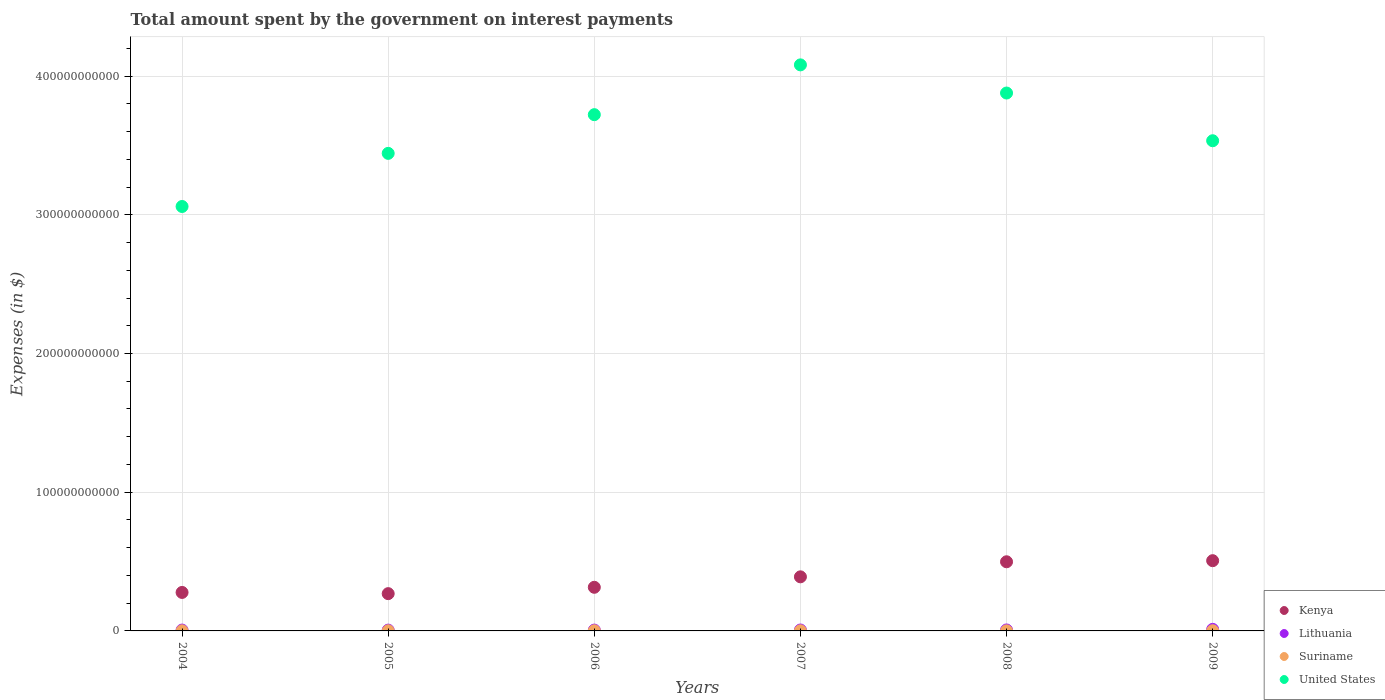Is the number of dotlines equal to the number of legend labels?
Provide a short and direct response. Yes. What is the amount spent on interest payments by the government in United States in 2004?
Your answer should be compact. 3.06e+11. Across all years, what is the maximum amount spent on interest payments by the government in Lithuania?
Offer a terse response. 1.13e+09. Across all years, what is the minimum amount spent on interest payments by the government in United States?
Give a very brief answer. 3.06e+11. In which year was the amount spent on interest payments by the government in Kenya maximum?
Provide a short and direct response. 2009. What is the total amount spent on interest payments by the government in Kenya in the graph?
Provide a succinct answer. 2.26e+11. What is the difference between the amount spent on interest payments by the government in Suriname in 2005 and that in 2007?
Give a very brief answer. 1.55e+05. What is the difference between the amount spent on interest payments by the government in United States in 2006 and the amount spent on interest payments by the government in Suriname in 2007?
Make the answer very short. 3.72e+11. What is the average amount spent on interest payments by the government in United States per year?
Your response must be concise. 3.62e+11. In the year 2006, what is the difference between the amount spent on interest payments by the government in Lithuania and amount spent on interest payments by the government in Kenya?
Provide a short and direct response. -3.09e+1. In how many years, is the amount spent on interest payments by the government in Suriname greater than 320000000000 $?
Give a very brief answer. 0. What is the ratio of the amount spent on interest payments by the government in United States in 2005 to that in 2007?
Offer a very short reply. 0.84. What is the difference between the highest and the second highest amount spent on interest payments by the government in Kenya?
Provide a succinct answer. 7.87e+08. What is the difference between the highest and the lowest amount spent on interest payments by the government in Suriname?
Keep it short and to the point. 7.16e+07. In how many years, is the amount spent on interest payments by the government in Kenya greater than the average amount spent on interest payments by the government in Kenya taken over all years?
Provide a short and direct response. 3. Is the sum of the amount spent on interest payments by the government in United States in 2005 and 2008 greater than the maximum amount spent on interest payments by the government in Suriname across all years?
Your answer should be very brief. Yes. Does the amount spent on interest payments by the government in United States monotonically increase over the years?
Ensure brevity in your answer.  No. How many dotlines are there?
Ensure brevity in your answer.  4. How many years are there in the graph?
Provide a short and direct response. 6. What is the difference between two consecutive major ticks on the Y-axis?
Give a very brief answer. 1.00e+11. Are the values on the major ticks of Y-axis written in scientific E-notation?
Give a very brief answer. No. Does the graph contain any zero values?
Provide a short and direct response. No. What is the title of the graph?
Ensure brevity in your answer.  Total amount spent by the government on interest payments. What is the label or title of the X-axis?
Your answer should be compact. Years. What is the label or title of the Y-axis?
Provide a succinct answer. Expenses (in $). What is the Expenses (in $) in Kenya in 2004?
Give a very brief answer. 2.77e+1. What is the Expenses (in $) in Lithuania in 2004?
Give a very brief answer. 6.10e+08. What is the Expenses (in $) of Suriname in 2004?
Your response must be concise. 6.82e+07. What is the Expenses (in $) in United States in 2004?
Your response must be concise. 3.06e+11. What is the Expenses (in $) in Kenya in 2005?
Make the answer very short. 2.69e+1. What is the Expenses (in $) in Lithuania in 2005?
Offer a very short reply. 5.87e+08. What is the Expenses (in $) in Suriname in 2005?
Your answer should be very brief. 9.73e+07. What is the Expenses (in $) of United States in 2005?
Offer a terse response. 3.44e+11. What is the Expenses (in $) of Kenya in 2006?
Your answer should be compact. 3.15e+1. What is the Expenses (in $) in Lithuania in 2006?
Ensure brevity in your answer.  6.00e+08. What is the Expenses (in $) in Suriname in 2006?
Ensure brevity in your answer.  1.08e+08. What is the Expenses (in $) in United States in 2006?
Provide a short and direct response. 3.72e+11. What is the Expenses (in $) of Kenya in 2007?
Give a very brief answer. 3.90e+1. What is the Expenses (in $) of Lithuania in 2007?
Offer a very short reply. 6.70e+08. What is the Expenses (in $) of Suriname in 2007?
Ensure brevity in your answer.  9.72e+07. What is the Expenses (in $) in United States in 2007?
Provide a short and direct response. 4.08e+11. What is the Expenses (in $) in Kenya in 2008?
Your response must be concise. 4.99e+1. What is the Expenses (in $) of Lithuania in 2008?
Your answer should be compact. 7.02e+08. What is the Expenses (in $) in Suriname in 2008?
Your answer should be very brief. 6.16e+07. What is the Expenses (in $) in United States in 2008?
Provide a short and direct response. 3.88e+11. What is the Expenses (in $) of Kenya in 2009?
Ensure brevity in your answer.  5.06e+1. What is the Expenses (in $) of Lithuania in 2009?
Ensure brevity in your answer.  1.13e+09. What is the Expenses (in $) of Suriname in 2009?
Your answer should be very brief. 1.33e+08. What is the Expenses (in $) in United States in 2009?
Provide a succinct answer. 3.53e+11. Across all years, what is the maximum Expenses (in $) in Kenya?
Provide a short and direct response. 5.06e+1. Across all years, what is the maximum Expenses (in $) of Lithuania?
Your answer should be compact. 1.13e+09. Across all years, what is the maximum Expenses (in $) of Suriname?
Your response must be concise. 1.33e+08. Across all years, what is the maximum Expenses (in $) of United States?
Make the answer very short. 4.08e+11. Across all years, what is the minimum Expenses (in $) of Kenya?
Provide a short and direct response. 2.69e+1. Across all years, what is the minimum Expenses (in $) in Lithuania?
Your answer should be very brief. 5.87e+08. Across all years, what is the minimum Expenses (in $) in Suriname?
Provide a succinct answer. 6.16e+07. Across all years, what is the minimum Expenses (in $) of United States?
Provide a short and direct response. 3.06e+11. What is the total Expenses (in $) in Kenya in the graph?
Your response must be concise. 2.26e+11. What is the total Expenses (in $) in Lithuania in the graph?
Your response must be concise. 4.30e+09. What is the total Expenses (in $) of Suriname in the graph?
Provide a succinct answer. 5.66e+08. What is the total Expenses (in $) of United States in the graph?
Provide a succinct answer. 2.17e+12. What is the difference between the Expenses (in $) in Kenya in 2004 and that in 2005?
Make the answer very short. 8.69e+08. What is the difference between the Expenses (in $) of Lithuania in 2004 and that in 2005?
Provide a short and direct response. 2.37e+07. What is the difference between the Expenses (in $) of Suriname in 2004 and that in 2005?
Your answer should be very brief. -2.91e+07. What is the difference between the Expenses (in $) of United States in 2004 and that in 2005?
Give a very brief answer. -3.83e+1. What is the difference between the Expenses (in $) of Kenya in 2004 and that in 2006?
Provide a short and direct response. -3.71e+09. What is the difference between the Expenses (in $) of Lithuania in 2004 and that in 2006?
Your answer should be very brief. 1.02e+07. What is the difference between the Expenses (in $) in Suriname in 2004 and that in 2006?
Provide a short and direct response. -4.02e+07. What is the difference between the Expenses (in $) of United States in 2004 and that in 2006?
Your answer should be compact. -6.62e+1. What is the difference between the Expenses (in $) in Kenya in 2004 and that in 2007?
Give a very brief answer. -1.13e+1. What is the difference between the Expenses (in $) in Lithuania in 2004 and that in 2007?
Offer a terse response. -6.00e+07. What is the difference between the Expenses (in $) of Suriname in 2004 and that in 2007?
Your answer should be very brief. -2.90e+07. What is the difference between the Expenses (in $) in United States in 2004 and that in 2007?
Keep it short and to the point. -1.02e+11. What is the difference between the Expenses (in $) in Kenya in 2004 and that in 2008?
Your answer should be very brief. -2.21e+1. What is the difference between the Expenses (in $) in Lithuania in 2004 and that in 2008?
Offer a terse response. -9.16e+07. What is the difference between the Expenses (in $) in Suriname in 2004 and that in 2008?
Your answer should be compact. 6.56e+06. What is the difference between the Expenses (in $) in United States in 2004 and that in 2008?
Make the answer very short. -8.18e+1. What is the difference between the Expenses (in $) in Kenya in 2004 and that in 2009?
Provide a short and direct response. -2.29e+1. What is the difference between the Expenses (in $) in Lithuania in 2004 and that in 2009?
Offer a very short reply. -5.17e+08. What is the difference between the Expenses (in $) in Suriname in 2004 and that in 2009?
Your answer should be very brief. -6.51e+07. What is the difference between the Expenses (in $) in United States in 2004 and that in 2009?
Make the answer very short. -4.74e+1. What is the difference between the Expenses (in $) of Kenya in 2005 and that in 2006?
Ensure brevity in your answer.  -4.58e+09. What is the difference between the Expenses (in $) of Lithuania in 2005 and that in 2006?
Make the answer very short. -1.35e+07. What is the difference between the Expenses (in $) in Suriname in 2005 and that in 2006?
Offer a very short reply. -1.11e+07. What is the difference between the Expenses (in $) of United States in 2005 and that in 2006?
Offer a very short reply. -2.79e+1. What is the difference between the Expenses (in $) of Kenya in 2005 and that in 2007?
Offer a very short reply. -1.21e+1. What is the difference between the Expenses (in $) in Lithuania in 2005 and that in 2007?
Make the answer very short. -8.37e+07. What is the difference between the Expenses (in $) in Suriname in 2005 and that in 2007?
Ensure brevity in your answer.  1.55e+05. What is the difference between the Expenses (in $) of United States in 2005 and that in 2007?
Offer a terse response. -6.38e+1. What is the difference between the Expenses (in $) of Kenya in 2005 and that in 2008?
Provide a short and direct response. -2.30e+1. What is the difference between the Expenses (in $) of Lithuania in 2005 and that in 2008?
Provide a succinct answer. -1.15e+08. What is the difference between the Expenses (in $) of Suriname in 2005 and that in 2008?
Your response must be concise. 3.57e+07. What is the difference between the Expenses (in $) of United States in 2005 and that in 2008?
Offer a very short reply. -4.35e+1. What is the difference between the Expenses (in $) of Kenya in 2005 and that in 2009?
Provide a short and direct response. -2.38e+1. What is the difference between the Expenses (in $) in Lithuania in 2005 and that in 2009?
Keep it short and to the point. -5.41e+08. What is the difference between the Expenses (in $) in Suriname in 2005 and that in 2009?
Provide a succinct answer. -3.60e+07. What is the difference between the Expenses (in $) in United States in 2005 and that in 2009?
Offer a terse response. -9.10e+09. What is the difference between the Expenses (in $) of Kenya in 2006 and that in 2007?
Ensure brevity in your answer.  -7.54e+09. What is the difference between the Expenses (in $) of Lithuania in 2006 and that in 2007?
Your response must be concise. -7.02e+07. What is the difference between the Expenses (in $) in Suriname in 2006 and that in 2007?
Offer a very short reply. 1.12e+07. What is the difference between the Expenses (in $) in United States in 2006 and that in 2007?
Offer a very short reply. -3.59e+1. What is the difference between the Expenses (in $) in Kenya in 2006 and that in 2008?
Your answer should be compact. -1.84e+1. What is the difference between the Expenses (in $) of Lithuania in 2006 and that in 2008?
Provide a short and direct response. -1.02e+08. What is the difference between the Expenses (in $) in Suriname in 2006 and that in 2008?
Your response must be concise. 4.68e+07. What is the difference between the Expenses (in $) in United States in 2006 and that in 2008?
Ensure brevity in your answer.  -1.56e+1. What is the difference between the Expenses (in $) in Kenya in 2006 and that in 2009?
Make the answer very short. -1.92e+1. What is the difference between the Expenses (in $) in Lithuania in 2006 and that in 2009?
Keep it short and to the point. -5.28e+08. What is the difference between the Expenses (in $) of Suriname in 2006 and that in 2009?
Provide a succinct answer. -2.49e+07. What is the difference between the Expenses (in $) of United States in 2006 and that in 2009?
Offer a very short reply. 1.88e+1. What is the difference between the Expenses (in $) in Kenya in 2007 and that in 2008?
Your answer should be very brief. -1.09e+1. What is the difference between the Expenses (in $) in Lithuania in 2007 and that in 2008?
Give a very brief answer. -3.16e+07. What is the difference between the Expenses (in $) of Suriname in 2007 and that in 2008?
Give a very brief answer. 3.55e+07. What is the difference between the Expenses (in $) in United States in 2007 and that in 2008?
Ensure brevity in your answer.  2.03e+1. What is the difference between the Expenses (in $) in Kenya in 2007 and that in 2009?
Your answer should be very brief. -1.16e+1. What is the difference between the Expenses (in $) in Lithuania in 2007 and that in 2009?
Provide a short and direct response. -4.57e+08. What is the difference between the Expenses (in $) in Suriname in 2007 and that in 2009?
Make the answer very short. -3.61e+07. What is the difference between the Expenses (in $) of United States in 2007 and that in 2009?
Provide a succinct answer. 5.47e+1. What is the difference between the Expenses (in $) in Kenya in 2008 and that in 2009?
Your answer should be very brief. -7.87e+08. What is the difference between the Expenses (in $) of Lithuania in 2008 and that in 2009?
Give a very brief answer. -4.26e+08. What is the difference between the Expenses (in $) in Suriname in 2008 and that in 2009?
Ensure brevity in your answer.  -7.16e+07. What is the difference between the Expenses (in $) in United States in 2008 and that in 2009?
Give a very brief answer. 3.44e+1. What is the difference between the Expenses (in $) of Kenya in 2004 and the Expenses (in $) of Lithuania in 2005?
Your answer should be very brief. 2.72e+1. What is the difference between the Expenses (in $) of Kenya in 2004 and the Expenses (in $) of Suriname in 2005?
Your answer should be very brief. 2.76e+1. What is the difference between the Expenses (in $) in Kenya in 2004 and the Expenses (in $) in United States in 2005?
Provide a succinct answer. -3.17e+11. What is the difference between the Expenses (in $) of Lithuania in 2004 and the Expenses (in $) of Suriname in 2005?
Your answer should be very brief. 5.13e+08. What is the difference between the Expenses (in $) in Lithuania in 2004 and the Expenses (in $) in United States in 2005?
Your answer should be very brief. -3.44e+11. What is the difference between the Expenses (in $) in Suriname in 2004 and the Expenses (in $) in United States in 2005?
Provide a short and direct response. -3.44e+11. What is the difference between the Expenses (in $) in Kenya in 2004 and the Expenses (in $) in Lithuania in 2006?
Provide a short and direct response. 2.71e+1. What is the difference between the Expenses (in $) in Kenya in 2004 and the Expenses (in $) in Suriname in 2006?
Your answer should be very brief. 2.76e+1. What is the difference between the Expenses (in $) in Kenya in 2004 and the Expenses (in $) in United States in 2006?
Offer a terse response. -3.44e+11. What is the difference between the Expenses (in $) of Lithuania in 2004 and the Expenses (in $) of Suriname in 2006?
Your answer should be very brief. 5.02e+08. What is the difference between the Expenses (in $) in Lithuania in 2004 and the Expenses (in $) in United States in 2006?
Give a very brief answer. -3.72e+11. What is the difference between the Expenses (in $) in Suriname in 2004 and the Expenses (in $) in United States in 2006?
Ensure brevity in your answer.  -3.72e+11. What is the difference between the Expenses (in $) in Kenya in 2004 and the Expenses (in $) in Lithuania in 2007?
Keep it short and to the point. 2.71e+1. What is the difference between the Expenses (in $) of Kenya in 2004 and the Expenses (in $) of Suriname in 2007?
Your response must be concise. 2.76e+1. What is the difference between the Expenses (in $) of Kenya in 2004 and the Expenses (in $) of United States in 2007?
Offer a terse response. -3.80e+11. What is the difference between the Expenses (in $) in Lithuania in 2004 and the Expenses (in $) in Suriname in 2007?
Provide a short and direct response. 5.13e+08. What is the difference between the Expenses (in $) of Lithuania in 2004 and the Expenses (in $) of United States in 2007?
Your answer should be very brief. -4.07e+11. What is the difference between the Expenses (in $) of Suriname in 2004 and the Expenses (in $) of United States in 2007?
Your answer should be compact. -4.08e+11. What is the difference between the Expenses (in $) in Kenya in 2004 and the Expenses (in $) in Lithuania in 2008?
Your response must be concise. 2.70e+1. What is the difference between the Expenses (in $) of Kenya in 2004 and the Expenses (in $) of Suriname in 2008?
Make the answer very short. 2.77e+1. What is the difference between the Expenses (in $) in Kenya in 2004 and the Expenses (in $) in United States in 2008?
Offer a very short reply. -3.60e+11. What is the difference between the Expenses (in $) of Lithuania in 2004 and the Expenses (in $) of Suriname in 2008?
Keep it short and to the point. 5.49e+08. What is the difference between the Expenses (in $) of Lithuania in 2004 and the Expenses (in $) of United States in 2008?
Offer a very short reply. -3.87e+11. What is the difference between the Expenses (in $) of Suriname in 2004 and the Expenses (in $) of United States in 2008?
Offer a very short reply. -3.88e+11. What is the difference between the Expenses (in $) in Kenya in 2004 and the Expenses (in $) in Lithuania in 2009?
Ensure brevity in your answer.  2.66e+1. What is the difference between the Expenses (in $) in Kenya in 2004 and the Expenses (in $) in Suriname in 2009?
Make the answer very short. 2.76e+1. What is the difference between the Expenses (in $) of Kenya in 2004 and the Expenses (in $) of United States in 2009?
Offer a very short reply. -3.26e+11. What is the difference between the Expenses (in $) of Lithuania in 2004 and the Expenses (in $) of Suriname in 2009?
Offer a terse response. 4.77e+08. What is the difference between the Expenses (in $) of Lithuania in 2004 and the Expenses (in $) of United States in 2009?
Your answer should be compact. -3.53e+11. What is the difference between the Expenses (in $) of Suriname in 2004 and the Expenses (in $) of United States in 2009?
Provide a succinct answer. -3.53e+11. What is the difference between the Expenses (in $) of Kenya in 2005 and the Expenses (in $) of Lithuania in 2006?
Offer a very short reply. 2.63e+1. What is the difference between the Expenses (in $) of Kenya in 2005 and the Expenses (in $) of Suriname in 2006?
Your answer should be compact. 2.68e+1. What is the difference between the Expenses (in $) of Kenya in 2005 and the Expenses (in $) of United States in 2006?
Your response must be concise. -3.45e+11. What is the difference between the Expenses (in $) of Lithuania in 2005 and the Expenses (in $) of Suriname in 2006?
Make the answer very short. 4.78e+08. What is the difference between the Expenses (in $) in Lithuania in 2005 and the Expenses (in $) in United States in 2006?
Your answer should be very brief. -3.72e+11. What is the difference between the Expenses (in $) of Suriname in 2005 and the Expenses (in $) of United States in 2006?
Your answer should be compact. -3.72e+11. What is the difference between the Expenses (in $) of Kenya in 2005 and the Expenses (in $) of Lithuania in 2007?
Give a very brief answer. 2.62e+1. What is the difference between the Expenses (in $) in Kenya in 2005 and the Expenses (in $) in Suriname in 2007?
Ensure brevity in your answer.  2.68e+1. What is the difference between the Expenses (in $) of Kenya in 2005 and the Expenses (in $) of United States in 2007?
Provide a short and direct response. -3.81e+11. What is the difference between the Expenses (in $) of Lithuania in 2005 and the Expenses (in $) of Suriname in 2007?
Offer a terse response. 4.90e+08. What is the difference between the Expenses (in $) of Lithuania in 2005 and the Expenses (in $) of United States in 2007?
Your response must be concise. -4.08e+11. What is the difference between the Expenses (in $) in Suriname in 2005 and the Expenses (in $) in United States in 2007?
Your response must be concise. -4.08e+11. What is the difference between the Expenses (in $) in Kenya in 2005 and the Expenses (in $) in Lithuania in 2008?
Provide a short and direct response. 2.62e+1. What is the difference between the Expenses (in $) in Kenya in 2005 and the Expenses (in $) in Suriname in 2008?
Keep it short and to the point. 2.68e+1. What is the difference between the Expenses (in $) in Kenya in 2005 and the Expenses (in $) in United States in 2008?
Offer a very short reply. -3.61e+11. What is the difference between the Expenses (in $) in Lithuania in 2005 and the Expenses (in $) in Suriname in 2008?
Offer a terse response. 5.25e+08. What is the difference between the Expenses (in $) of Lithuania in 2005 and the Expenses (in $) of United States in 2008?
Give a very brief answer. -3.87e+11. What is the difference between the Expenses (in $) of Suriname in 2005 and the Expenses (in $) of United States in 2008?
Make the answer very short. -3.88e+11. What is the difference between the Expenses (in $) of Kenya in 2005 and the Expenses (in $) of Lithuania in 2009?
Ensure brevity in your answer.  2.57e+1. What is the difference between the Expenses (in $) of Kenya in 2005 and the Expenses (in $) of Suriname in 2009?
Make the answer very short. 2.67e+1. What is the difference between the Expenses (in $) in Kenya in 2005 and the Expenses (in $) in United States in 2009?
Offer a terse response. -3.27e+11. What is the difference between the Expenses (in $) of Lithuania in 2005 and the Expenses (in $) of Suriname in 2009?
Make the answer very short. 4.54e+08. What is the difference between the Expenses (in $) of Lithuania in 2005 and the Expenses (in $) of United States in 2009?
Provide a succinct answer. -3.53e+11. What is the difference between the Expenses (in $) in Suriname in 2005 and the Expenses (in $) in United States in 2009?
Offer a very short reply. -3.53e+11. What is the difference between the Expenses (in $) in Kenya in 2006 and the Expenses (in $) in Lithuania in 2007?
Provide a succinct answer. 3.08e+1. What is the difference between the Expenses (in $) of Kenya in 2006 and the Expenses (in $) of Suriname in 2007?
Make the answer very short. 3.14e+1. What is the difference between the Expenses (in $) in Kenya in 2006 and the Expenses (in $) in United States in 2007?
Offer a terse response. -3.77e+11. What is the difference between the Expenses (in $) of Lithuania in 2006 and the Expenses (in $) of Suriname in 2007?
Ensure brevity in your answer.  5.03e+08. What is the difference between the Expenses (in $) of Lithuania in 2006 and the Expenses (in $) of United States in 2007?
Keep it short and to the point. -4.07e+11. What is the difference between the Expenses (in $) in Suriname in 2006 and the Expenses (in $) in United States in 2007?
Your answer should be very brief. -4.08e+11. What is the difference between the Expenses (in $) of Kenya in 2006 and the Expenses (in $) of Lithuania in 2008?
Your response must be concise. 3.08e+1. What is the difference between the Expenses (in $) of Kenya in 2006 and the Expenses (in $) of Suriname in 2008?
Keep it short and to the point. 3.14e+1. What is the difference between the Expenses (in $) in Kenya in 2006 and the Expenses (in $) in United States in 2008?
Provide a short and direct response. -3.56e+11. What is the difference between the Expenses (in $) in Lithuania in 2006 and the Expenses (in $) in Suriname in 2008?
Ensure brevity in your answer.  5.39e+08. What is the difference between the Expenses (in $) of Lithuania in 2006 and the Expenses (in $) of United States in 2008?
Make the answer very short. -3.87e+11. What is the difference between the Expenses (in $) of Suriname in 2006 and the Expenses (in $) of United States in 2008?
Keep it short and to the point. -3.88e+11. What is the difference between the Expenses (in $) of Kenya in 2006 and the Expenses (in $) of Lithuania in 2009?
Your answer should be compact. 3.03e+1. What is the difference between the Expenses (in $) of Kenya in 2006 and the Expenses (in $) of Suriname in 2009?
Offer a terse response. 3.13e+1. What is the difference between the Expenses (in $) in Kenya in 2006 and the Expenses (in $) in United States in 2009?
Your response must be concise. -3.22e+11. What is the difference between the Expenses (in $) of Lithuania in 2006 and the Expenses (in $) of Suriname in 2009?
Provide a short and direct response. 4.67e+08. What is the difference between the Expenses (in $) of Lithuania in 2006 and the Expenses (in $) of United States in 2009?
Keep it short and to the point. -3.53e+11. What is the difference between the Expenses (in $) in Suriname in 2006 and the Expenses (in $) in United States in 2009?
Provide a succinct answer. -3.53e+11. What is the difference between the Expenses (in $) in Kenya in 2007 and the Expenses (in $) in Lithuania in 2008?
Make the answer very short. 3.83e+1. What is the difference between the Expenses (in $) in Kenya in 2007 and the Expenses (in $) in Suriname in 2008?
Your response must be concise. 3.89e+1. What is the difference between the Expenses (in $) in Kenya in 2007 and the Expenses (in $) in United States in 2008?
Make the answer very short. -3.49e+11. What is the difference between the Expenses (in $) of Lithuania in 2007 and the Expenses (in $) of Suriname in 2008?
Your answer should be compact. 6.09e+08. What is the difference between the Expenses (in $) in Lithuania in 2007 and the Expenses (in $) in United States in 2008?
Keep it short and to the point. -3.87e+11. What is the difference between the Expenses (in $) of Suriname in 2007 and the Expenses (in $) of United States in 2008?
Your answer should be compact. -3.88e+11. What is the difference between the Expenses (in $) in Kenya in 2007 and the Expenses (in $) in Lithuania in 2009?
Your response must be concise. 3.79e+1. What is the difference between the Expenses (in $) in Kenya in 2007 and the Expenses (in $) in Suriname in 2009?
Keep it short and to the point. 3.89e+1. What is the difference between the Expenses (in $) in Kenya in 2007 and the Expenses (in $) in United States in 2009?
Your answer should be compact. -3.14e+11. What is the difference between the Expenses (in $) of Lithuania in 2007 and the Expenses (in $) of Suriname in 2009?
Your answer should be very brief. 5.37e+08. What is the difference between the Expenses (in $) in Lithuania in 2007 and the Expenses (in $) in United States in 2009?
Give a very brief answer. -3.53e+11. What is the difference between the Expenses (in $) in Suriname in 2007 and the Expenses (in $) in United States in 2009?
Provide a succinct answer. -3.53e+11. What is the difference between the Expenses (in $) of Kenya in 2008 and the Expenses (in $) of Lithuania in 2009?
Offer a very short reply. 4.87e+1. What is the difference between the Expenses (in $) in Kenya in 2008 and the Expenses (in $) in Suriname in 2009?
Offer a terse response. 4.97e+1. What is the difference between the Expenses (in $) in Kenya in 2008 and the Expenses (in $) in United States in 2009?
Give a very brief answer. -3.04e+11. What is the difference between the Expenses (in $) in Lithuania in 2008 and the Expenses (in $) in Suriname in 2009?
Offer a very short reply. 5.69e+08. What is the difference between the Expenses (in $) in Lithuania in 2008 and the Expenses (in $) in United States in 2009?
Offer a very short reply. -3.53e+11. What is the difference between the Expenses (in $) in Suriname in 2008 and the Expenses (in $) in United States in 2009?
Make the answer very short. -3.53e+11. What is the average Expenses (in $) of Kenya per year?
Give a very brief answer. 3.76e+1. What is the average Expenses (in $) in Lithuania per year?
Provide a succinct answer. 7.16e+08. What is the average Expenses (in $) of Suriname per year?
Your response must be concise. 9.43e+07. What is the average Expenses (in $) in United States per year?
Provide a succinct answer. 3.62e+11. In the year 2004, what is the difference between the Expenses (in $) of Kenya and Expenses (in $) of Lithuania?
Provide a short and direct response. 2.71e+1. In the year 2004, what is the difference between the Expenses (in $) in Kenya and Expenses (in $) in Suriname?
Your response must be concise. 2.77e+1. In the year 2004, what is the difference between the Expenses (in $) of Kenya and Expenses (in $) of United States?
Ensure brevity in your answer.  -2.78e+11. In the year 2004, what is the difference between the Expenses (in $) of Lithuania and Expenses (in $) of Suriname?
Ensure brevity in your answer.  5.42e+08. In the year 2004, what is the difference between the Expenses (in $) in Lithuania and Expenses (in $) in United States?
Your answer should be very brief. -3.05e+11. In the year 2004, what is the difference between the Expenses (in $) in Suriname and Expenses (in $) in United States?
Make the answer very short. -3.06e+11. In the year 2005, what is the difference between the Expenses (in $) in Kenya and Expenses (in $) in Lithuania?
Offer a terse response. 2.63e+1. In the year 2005, what is the difference between the Expenses (in $) in Kenya and Expenses (in $) in Suriname?
Keep it short and to the point. 2.68e+1. In the year 2005, what is the difference between the Expenses (in $) in Kenya and Expenses (in $) in United States?
Ensure brevity in your answer.  -3.17e+11. In the year 2005, what is the difference between the Expenses (in $) of Lithuania and Expenses (in $) of Suriname?
Your answer should be very brief. 4.89e+08. In the year 2005, what is the difference between the Expenses (in $) in Lithuania and Expenses (in $) in United States?
Your answer should be very brief. -3.44e+11. In the year 2005, what is the difference between the Expenses (in $) in Suriname and Expenses (in $) in United States?
Provide a succinct answer. -3.44e+11. In the year 2006, what is the difference between the Expenses (in $) of Kenya and Expenses (in $) of Lithuania?
Your answer should be compact. 3.09e+1. In the year 2006, what is the difference between the Expenses (in $) in Kenya and Expenses (in $) in Suriname?
Offer a terse response. 3.13e+1. In the year 2006, what is the difference between the Expenses (in $) of Kenya and Expenses (in $) of United States?
Make the answer very short. -3.41e+11. In the year 2006, what is the difference between the Expenses (in $) of Lithuania and Expenses (in $) of Suriname?
Offer a terse response. 4.92e+08. In the year 2006, what is the difference between the Expenses (in $) in Lithuania and Expenses (in $) in United States?
Your answer should be very brief. -3.72e+11. In the year 2006, what is the difference between the Expenses (in $) in Suriname and Expenses (in $) in United States?
Ensure brevity in your answer.  -3.72e+11. In the year 2007, what is the difference between the Expenses (in $) in Kenya and Expenses (in $) in Lithuania?
Give a very brief answer. 3.83e+1. In the year 2007, what is the difference between the Expenses (in $) in Kenya and Expenses (in $) in Suriname?
Make the answer very short. 3.89e+1. In the year 2007, what is the difference between the Expenses (in $) in Kenya and Expenses (in $) in United States?
Offer a very short reply. -3.69e+11. In the year 2007, what is the difference between the Expenses (in $) in Lithuania and Expenses (in $) in Suriname?
Provide a short and direct response. 5.73e+08. In the year 2007, what is the difference between the Expenses (in $) in Lithuania and Expenses (in $) in United States?
Your answer should be compact. -4.07e+11. In the year 2007, what is the difference between the Expenses (in $) of Suriname and Expenses (in $) of United States?
Keep it short and to the point. -4.08e+11. In the year 2008, what is the difference between the Expenses (in $) in Kenya and Expenses (in $) in Lithuania?
Give a very brief answer. 4.92e+1. In the year 2008, what is the difference between the Expenses (in $) of Kenya and Expenses (in $) of Suriname?
Offer a terse response. 4.98e+1. In the year 2008, what is the difference between the Expenses (in $) in Kenya and Expenses (in $) in United States?
Make the answer very short. -3.38e+11. In the year 2008, what is the difference between the Expenses (in $) in Lithuania and Expenses (in $) in Suriname?
Offer a terse response. 6.40e+08. In the year 2008, what is the difference between the Expenses (in $) of Lithuania and Expenses (in $) of United States?
Keep it short and to the point. -3.87e+11. In the year 2008, what is the difference between the Expenses (in $) in Suriname and Expenses (in $) in United States?
Keep it short and to the point. -3.88e+11. In the year 2009, what is the difference between the Expenses (in $) of Kenya and Expenses (in $) of Lithuania?
Provide a short and direct response. 4.95e+1. In the year 2009, what is the difference between the Expenses (in $) of Kenya and Expenses (in $) of Suriname?
Provide a short and direct response. 5.05e+1. In the year 2009, what is the difference between the Expenses (in $) in Kenya and Expenses (in $) in United States?
Provide a succinct answer. -3.03e+11. In the year 2009, what is the difference between the Expenses (in $) of Lithuania and Expenses (in $) of Suriname?
Offer a very short reply. 9.95e+08. In the year 2009, what is the difference between the Expenses (in $) in Lithuania and Expenses (in $) in United States?
Your response must be concise. -3.52e+11. In the year 2009, what is the difference between the Expenses (in $) of Suriname and Expenses (in $) of United States?
Ensure brevity in your answer.  -3.53e+11. What is the ratio of the Expenses (in $) in Kenya in 2004 to that in 2005?
Offer a very short reply. 1.03. What is the ratio of the Expenses (in $) of Lithuania in 2004 to that in 2005?
Provide a succinct answer. 1.04. What is the ratio of the Expenses (in $) of Suriname in 2004 to that in 2005?
Your answer should be compact. 0.7. What is the ratio of the Expenses (in $) in United States in 2004 to that in 2005?
Provide a succinct answer. 0.89. What is the ratio of the Expenses (in $) in Kenya in 2004 to that in 2006?
Keep it short and to the point. 0.88. What is the ratio of the Expenses (in $) in Lithuania in 2004 to that in 2006?
Offer a terse response. 1.02. What is the ratio of the Expenses (in $) in Suriname in 2004 to that in 2006?
Ensure brevity in your answer.  0.63. What is the ratio of the Expenses (in $) in United States in 2004 to that in 2006?
Offer a terse response. 0.82. What is the ratio of the Expenses (in $) in Kenya in 2004 to that in 2007?
Your answer should be very brief. 0.71. What is the ratio of the Expenses (in $) of Lithuania in 2004 to that in 2007?
Give a very brief answer. 0.91. What is the ratio of the Expenses (in $) in Suriname in 2004 to that in 2007?
Offer a terse response. 0.7. What is the ratio of the Expenses (in $) of United States in 2004 to that in 2007?
Ensure brevity in your answer.  0.75. What is the ratio of the Expenses (in $) of Kenya in 2004 to that in 2008?
Ensure brevity in your answer.  0.56. What is the ratio of the Expenses (in $) in Lithuania in 2004 to that in 2008?
Give a very brief answer. 0.87. What is the ratio of the Expenses (in $) in Suriname in 2004 to that in 2008?
Offer a terse response. 1.11. What is the ratio of the Expenses (in $) in United States in 2004 to that in 2008?
Your answer should be very brief. 0.79. What is the ratio of the Expenses (in $) of Kenya in 2004 to that in 2009?
Provide a short and direct response. 0.55. What is the ratio of the Expenses (in $) in Lithuania in 2004 to that in 2009?
Your response must be concise. 0.54. What is the ratio of the Expenses (in $) of Suriname in 2004 to that in 2009?
Provide a short and direct response. 0.51. What is the ratio of the Expenses (in $) of United States in 2004 to that in 2009?
Your answer should be very brief. 0.87. What is the ratio of the Expenses (in $) of Kenya in 2005 to that in 2006?
Give a very brief answer. 0.85. What is the ratio of the Expenses (in $) of Lithuania in 2005 to that in 2006?
Your response must be concise. 0.98. What is the ratio of the Expenses (in $) in Suriname in 2005 to that in 2006?
Ensure brevity in your answer.  0.9. What is the ratio of the Expenses (in $) of United States in 2005 to that in 2006?
Give a very brief answer. 0.93. What is the ratio of the Expenses (in $) of Kenya in 2005 to that in 2007?
Your answer should be very brief. 0.69. What is the ratio of the Expenses (in $) of Lithuania in 2005 to that in 2007?
Your response must be concise. 0.88. What is the ratio of the Expenses (in $) of United States in 2005 to that in 2007?
Your answer should be compact. 0.84. What is the ratio of the Expenses (in $) of Kenya in 2005 to that in 2008?
Offer a very short reply. 0.54. What is the ratio of the Expenses (in $) in Lithuania in 2005 to that in 2008?
Your answer should be compact. 0.84. What is the ratio of the Expenses (in $) in Suriname in 2005 to that in 2008?
Your response must be concise. 1.58. What is the ratio of the Expenses (in $) of United States in 2005 to that in 2008?
Your answer should be very brief. 0.89. What is the ratio of the Expenses (in $) of Kenya in 2005 to that in 2009?
Ensure brevity in your answer.  0.53. What is the ratio of the Expenses (in $) in Lithuania in 2005 to that in 2009?
Provide a succinct answer. 0.52. What is the ratio of the Expenses (in $) in Suriname in 2005 to that in 2009?
Provide a short and direct response. 0.73. What is the ratio of the Expenses (in $) of United States in 2005 to that in 2009?
Your answer should be very brief. 0.97. What is the ratio of the Expenses (in $) of Kenya in 2006 to that in 2007?
Your response must be concise. 0.81. What is the ratio of the Expenses (in $) in Lithuania in 2006 to that in 2007?
Offer a terse response. 0.9. What is the ratio of the Expenses (in $) of Suriname in 2006 to that in 2007?
Offer a terse response. 1.12. What is the ratio of the Expenses (in $) of United States in 2006 to that in 2007?
Make the answer very short. 0.91. What is the ratio of the Expenses (in $) in Kenya in 2006 to that in 2008?
Make the answer very short. 0.63. What is the ratio of the Expenses (in $) of Lithuania in 2006 to that in 2008?
Give a very brief answer. 0.85. What is the ratio of the Expenses (in $) in Suriname in 2006 to that in 2008?
Keep it short and to the point. 1.76. What is the ratio of the Expenses (in $) of United States in 2006 to that in 2008?
Offer a terse response. 0.96. What is the ratio of the Expenses (in $) in Kenya in 2006 to that in 2009?
Provide a short and direct response. 0.62. What is the ratio of the Expenses (in $) of Lithuania in 2006 to that in 2009?
Your answer should be compact. 0.53. What is the ratio of the Expenses (in $) in Suriname in 2006 to that in 2009?
Provide a short and direct response. 0.81. What is the ratio of the Expenses (in $) of United States in 2006 to that in 2009?
Ensure brevity in your answer.  1.05. What is the ratio of the Expenses (in $) in Kenya in 2007 to that in 2008?
Give a very brief answer. 0.78. What is the ratio of the Expenses (in $) of Lithuania in 2007 to that in 2008?
Your answer should be very brief. 0.95. What is the ratio of the Expenses (in $) in Suriname in 2007 to that in 2008?
Your answer should be compact. 1.58. What is the ratio of the Expenses (in $) in United States in 2007 to that in 2008?
Ensure brevity in your answer.  1.05. What is the ratio of the Expenses (in $) in Kenya in 2007 to that in 2009?
Provide a succinct answer. 0.77. What is the ratio of the Expenses (in $) of Lithuania in 2007 to that in 2009?
Keep it short and to the point. 0.59. What is the ratio of the Expenses (in $) of Suriname in 2007 to that in 2009?
Provide a short and direct response. 0.73. What is the ratio of the Expenses (in $) in United States in 2007 to that in 2009?
Offer a terse response. 1.15. What is the ratio of the Expenses (in $) of Kenya in 2008 to that in 2009?
Provide a short and direct response. 0.98. What is the ratio of the Expenses (in $) of Lithuania in 2008 to that in 2009?
Your response must be concise. 0.62. What is the ratio of the Expenses (in $) of Suriname in 2008 to that in 2009?
Provide a succinct answer. 0.46. What is the ratio of the Expenses (in $) of United States in 2008 to that in 2009?
Your answer should be very brief. 1.1. What is the difference between the highest and the second highest Expenses (in $) of Kenya?
Your response must be concise. 7.87e+08. What is the difference between the highest and the second highest Expenses (in $) in Lithuania?
Provide a succinct answer. 4.26e+08. What is the difference between the highest and the second highest Expenses (in $) in Suriname?
Your answer should be compact. 2.49e+07. What is the difference between the highest and the second highest Expenses (in $) in United States?
Ensure brevity in your answer.  2.03e+1. What is the difference between the highest and the lowest Expenses (in $) in Kenya?
Provide a short and direct response. 2.38e+1. What is the difference between the highest and the lowest Expenses (in $) of Lithuania?
Make the answer very short. 5.41e+08. What is the difference between the highest and the lowest Expenses (in $) in Suriname?
Give a very brief answer. 7.16e+07. What is the difference between the highest and the lowest Expenses (in $) in United States?
Ensure brevity in your answer.  1.02e+11. 